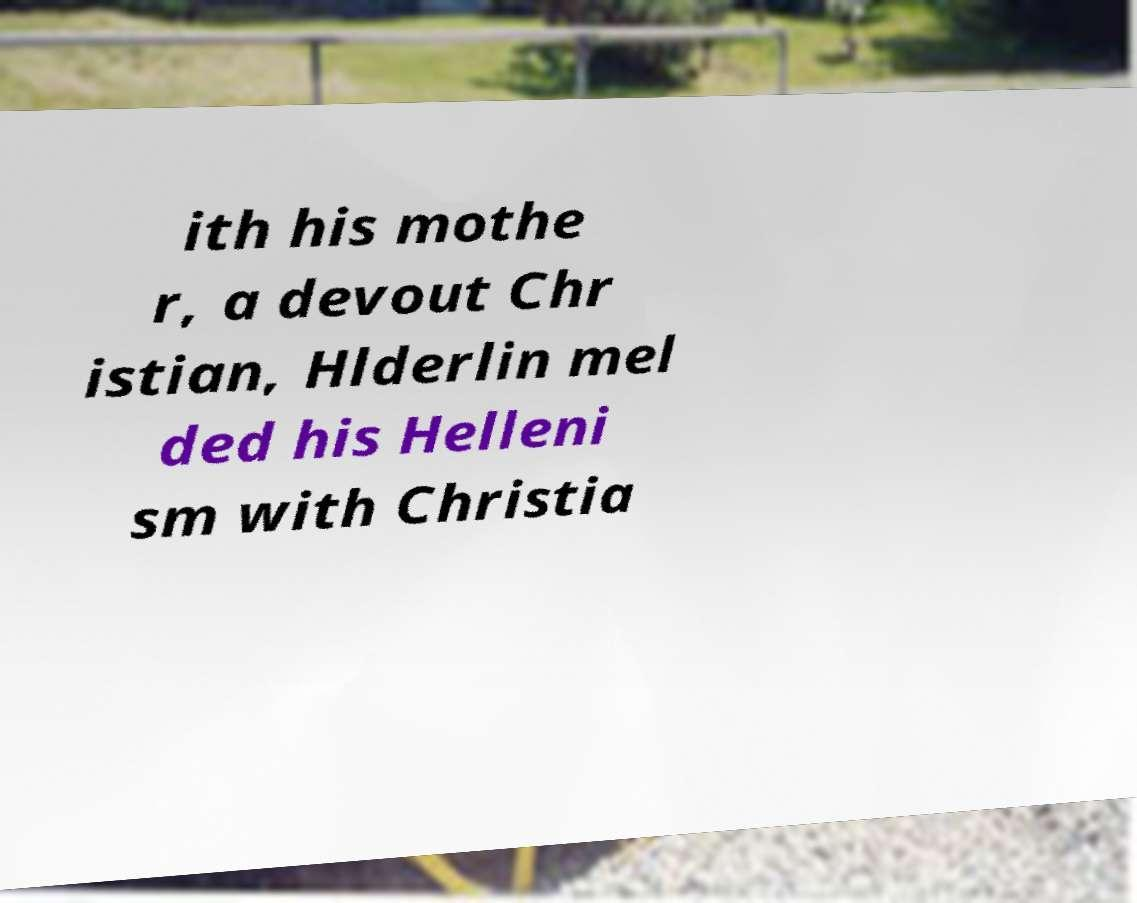There's text embedded in this image that I need extracted. Can you transcribe it verbatim? ith his mothe r, a devout Chr istian, Hlderlin mel ded his Helleni sm with Christia 